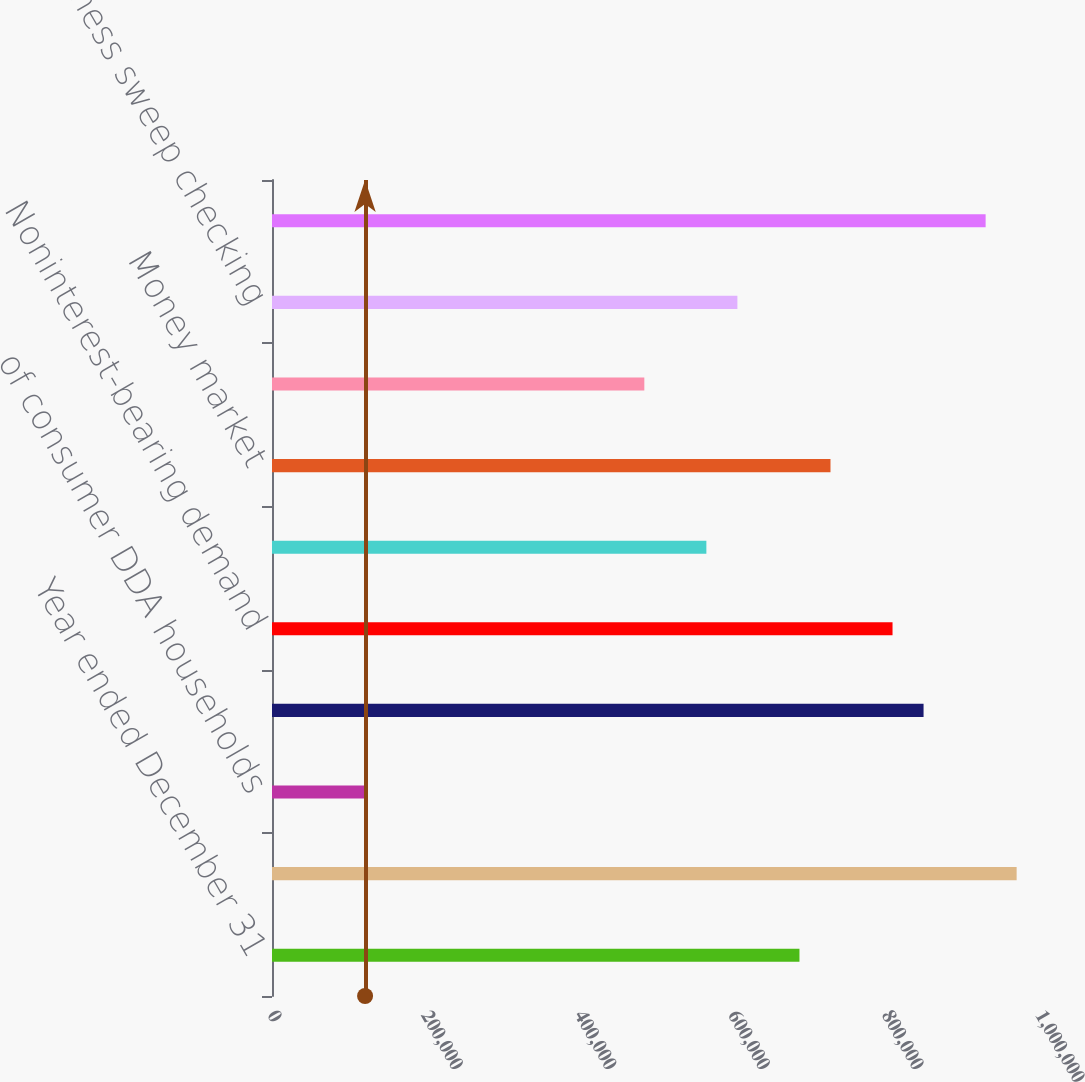Convert chart to OTSL. <chart><loc_0><loc_0><loc_500><loc_500><bar_chart><fcel>Year ended December 31<fcel>Consumer DDA households using<fcel>of consumer DDA households<fcel>Small business loans<fcel>Noninterest-bearing demand<fcel>Interest-bearing demand<fcel>Money market<fcel>Certificates of deposit<fcel>Small business sweep checking<fcel>Total managed deposits<nl><fcel>686794<fcel>969589<fcel>121206<fcel>848391<fcel>807992<fcel>565597<fcel>727194<fcel>484798<fcel>605996<fcel>929190<nl></chart> 